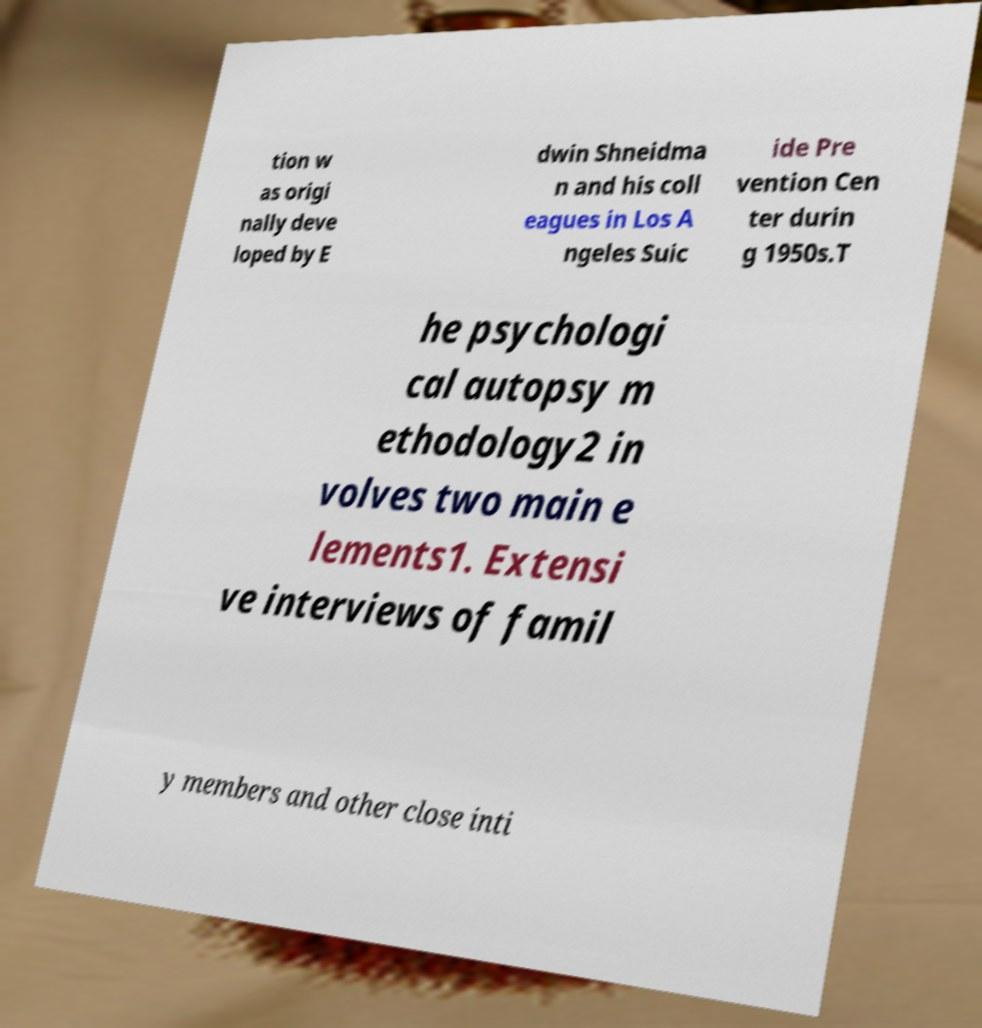There's text embedded in this image that I need extracted. Can you transcribe it verbatim? tion w as origi nally deve loped by E dwin Shneidma n and his coll eagues in Los A ngeles Suic ide Pre vention Cen ter durin g 1950s.T he psychologi cal autopsy m ethodology2 in volves two main e lements1. Extensi ve interviews of famil y members and other close inti 